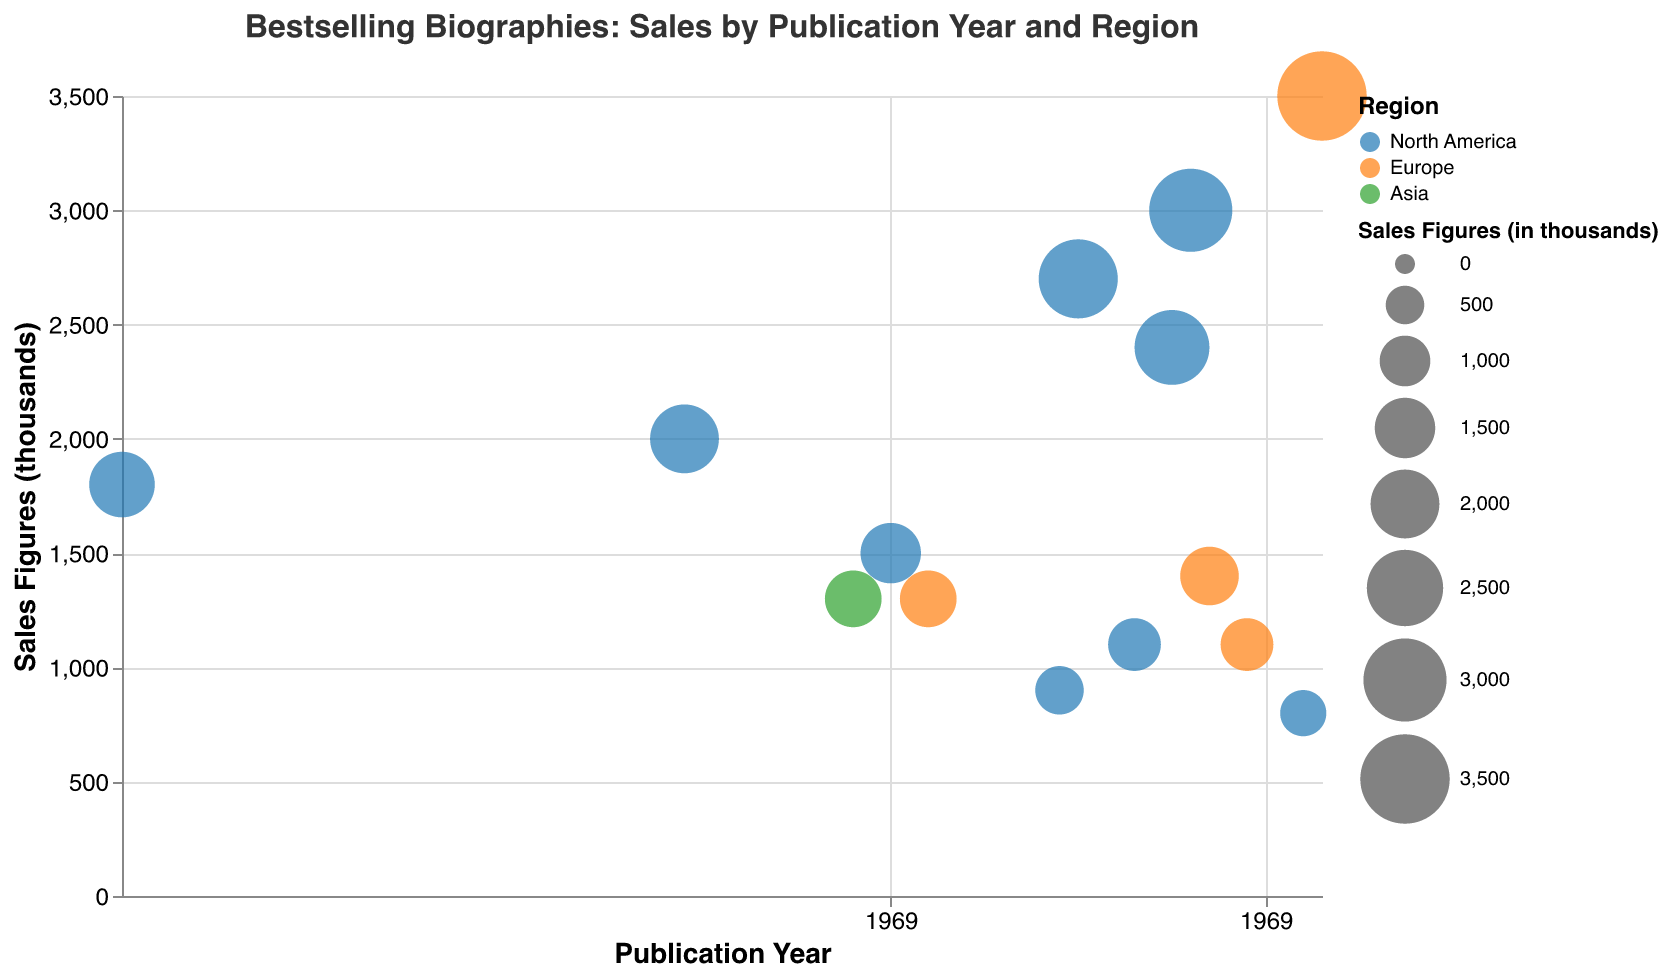What is the title of the chart? The title of the chart is prominently displayed at the top. It reads "Bestselling Biographies: Sales by Publication Year and Region".
Answer: Bestselling Biographies: Sales by Publication Year and Region Which region has the biography with the highest sales figures? The largest bubble in the chart indicates the highest sales figures. It is colored orange, which corresponds to Europe. The tooltip confirms that the title is "Becoming" by Michelle Obama with sales of 3500 thousand.
Answer: Europe How many biographies from North America are present in the chart? The different regions are color-coded. By counting the number of blue bubbles (North America), there are a total of 8 biographies from this region.
Answer: 8 Which biography published in 2011 has the highest sales figures? There is only one bubble for the year 2011, colored blue (North America). By checking the tooltip, the title is "Steve Jobs" by Walter Isaacson with sales of 3000 thousand.
Answer: Steve Jobs What is the average sales figure for the biographies published in Europe? First, identify the sales figures for the European biographies: 3500, 1400, 1300, 1100. Then, calculate the average: (3500 + 1400 + 1300 + 1100) / 4 = 1825 thousand.
Answer: 1825 Compare the sales figures of "Eat Pray Love" and "I Know Why the Caged Bird Sings". Which one sold more copies? Check the bubbles for "Eat Pray Love" and "I Know Why the Caged Bird Sings". "Eat Pray Love" shows 2400 thousand while "I Know Why the Caged Bird Sings" shows 2000 thousand. So, "Eat Pray Love" sold more copies.
Answer: Eat Pray Love Which author has the earliest publication year in the chart? By looking at the axis, the earliest year is 1954. The tooltip confirms that the author is Helen Keller for "The Story of My Life".
Answer: Helen Keller What's the total sales figure for books published after 2010? Identify and sum the sales figures for books published after 2010: 3000 (Steve Jobs) + 1400 (Bossypants) + 1100 (Not That Kind of Girl) + 800 (The Sun Does Shine) + 3500 (Becoming) = 9800 thousand.
Answer: 9800 What can be inferred about the popularity of biographies over time? Observing the size and distribution of the bubbles across years, it indicates that more recent biographies (post-2000) generally have larger bubbles, showing higher sales, suggesting an increasing popularity over time.
Answer: Increasing popularity over time How do the sales figures for biographies from Asia compare to other regions? There is only one bubble for Asia with sales of 1300 thousand. This is generally lower compared to the highest sales figures in North America and Europe, suggesting fewer bestselling biographies from Asia in this data set.
Answer: Asia has fewer bestselling biographies 